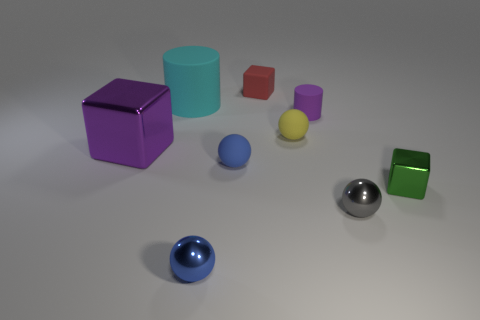What color is the small sphere behind the large purple object?
Provide a short and direct response. Yellow. What material is the big block that is the same color as the small matte cylinder?
Your answer should be compact. Metal. What number of tiny cubes have the same color as the big cylinder?
Make the answer very short. 0. Do the gray metal sphere and the cube on the left side of the large cyan cylinder have the same size?
Keep it short and to the point. No. There is a metallic block that is to the right of the metal sphere on the left side of the cylinder that is on the right side of the blue matte object; how big is it?
Your response must be concise. Small. How many tiny objects are to the right of the small gray shiny sphere?
Provide a short and direct response. 1. What is the small blue thing behind the block right of the red rubber thing made of?
Your answer should be very brief. Rubber. Is the red rubber thing the same size as the cyan thing?
Your answer should be very brief. No. What number of things are purple objects in front of the cyan rubber cylinder or blocks that are in front of the small red rubber cube?
Provide a short and direct response. 3. Are there more big cyan matte cylinders behind the tiny blue shiny ball than green rubber cylinders?
Offer a terse response. Yes. 